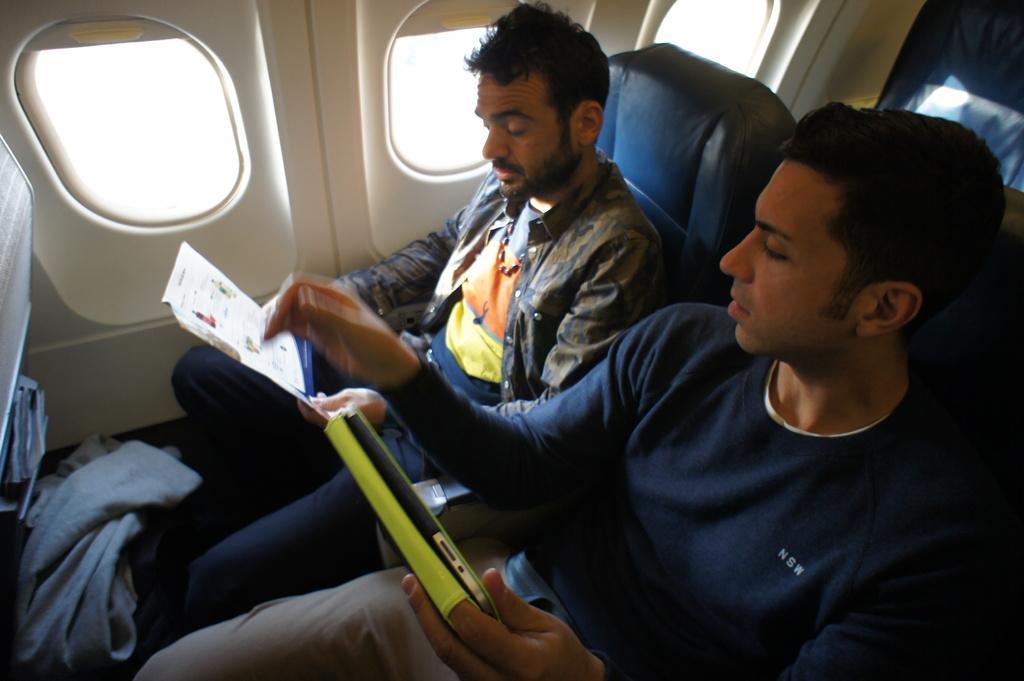Describe this image in one or two sentences. This is an inside view of an aeroplane. Here two men are sitting on the seats. One man is holding a device in the hand and another man is holding a book and looking into the book. 